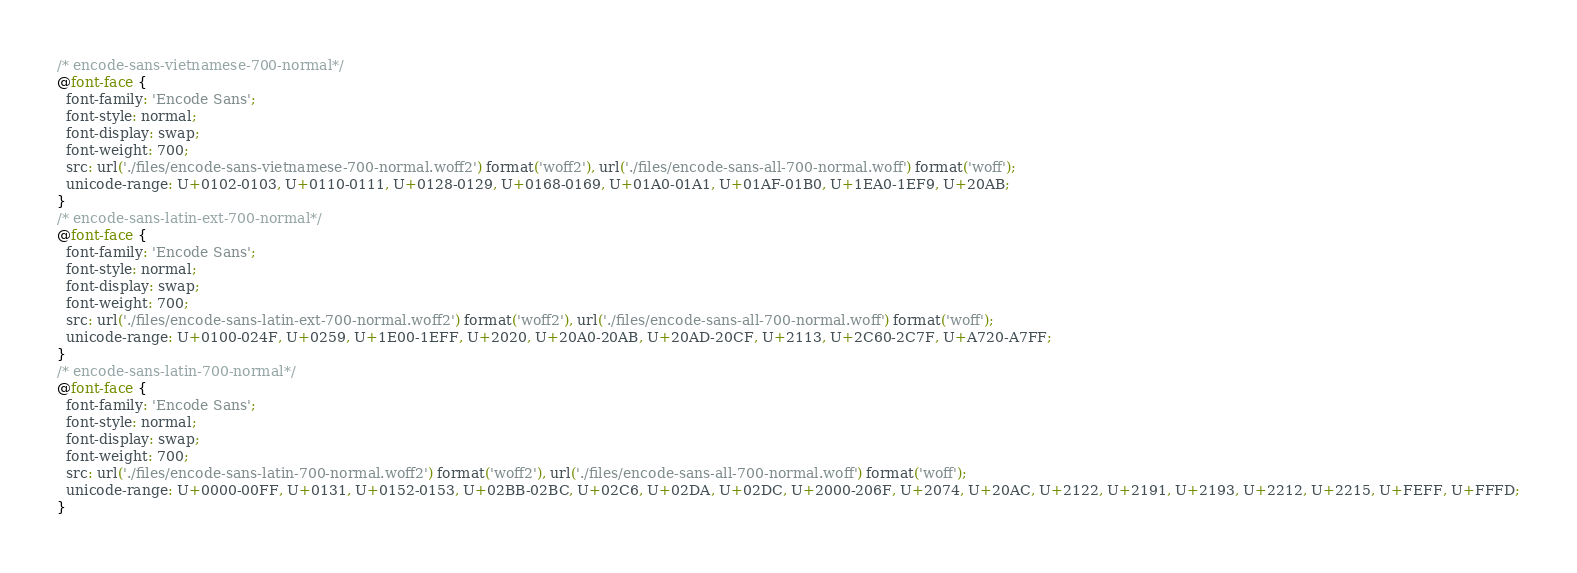<code> <loc_0><loc_0><loc_500><loc_500><_CSS_>/* encode-sans-vietnamese-700-normal*/
@font-face {
  font-family: 'Encode Sans';
  font-style: normal;
  font-display: swap;
  font-weight: 700;
  src: url('./files/encode-sans-vietnamese-700-normal.woff2') format('woff2'), url('./files/encode-sans-all-700-normal.woff') format('woff');
  unicode-range: U+0102-0103, U+0110-0111, U+0128-0129, U+0168-0169, U+01A0-01A1, U+01AF-01B0, U+1EA0-1EF9, U+20AB;
}
/* encode-sans-latin-ext-700-normal*/
@font-face {
  font-family: 'Encode Sans';
  font-style: normal;
  font-display: swap;
  font-weight: 700;
  src: url('./files/encode-sans-latin-ext-700-normal.woff2') format('woff2'), url('./files/encode-sans-all-700-normal.woff') format('woff');
  unicode-range: U+0100-024F, U+0259, U+1E00-1EFF, U+2020, U+20A0-20AB, U+20AD-20CF, U+2113, U+2C60-2C7F, U+A720-A7FF;
}
/* encode-sans-latin-700-normal*/
@font-face {
  font-family: 'Encode Sans';
  font-style: normal;
  font-display: swap;
  font-weight: 700;
  src: url('./files/encode-sans-latin-700-normal.woff2') format('woff2'), url('./files/encode-sans-all-700-normal.woff') format('woff');
  unicode-range: U+0000-00FF, U+0131, U+0152-0153, U+02BB-02BC, U+02C6, U+02DA, U+02DC, U+2000-206F, U+2074, U+20AC, U+2122, U+2191, U+2193, U+2212, U+2215, U+FEFF, U+FFFD;
}
</code> 